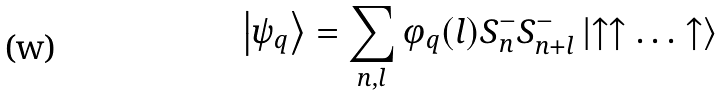Convert formula to latex. <formula><loc_0><loc_0><loc_500><loc_500>\left | \psi _ { q } \right \rangle = \sum _ { n , l } \varphi _ { q } ( l ) S _ { n } ^ { - } S _ { n + l } ^ { - } \left | \uparrow \uparrow \dots \uparrow \right \rangle</formula> 